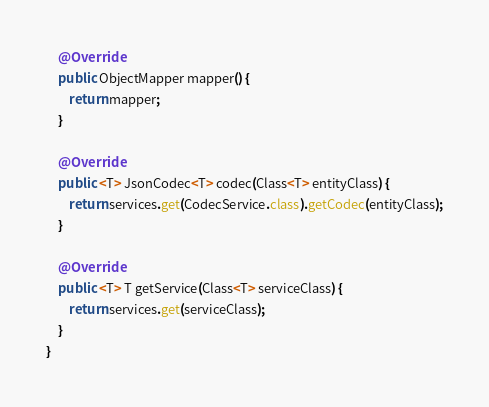Convert code to text. <code><loc_0><loc_0><loc_500><loc_500><_Java_>
    @Override
    public ObjectMapper mapper() {
        return mapper;
    }

    @Override
    public <T> JsonCodec<T> codec(Class<T> entityClass) {
        return services.get(CodecService.class).getCodec(entityClass);
    }

    @Override
    public <T> T getService(Class<T> serviceClass) {
        return services.get(serviceClass);
    }
}
</code> 